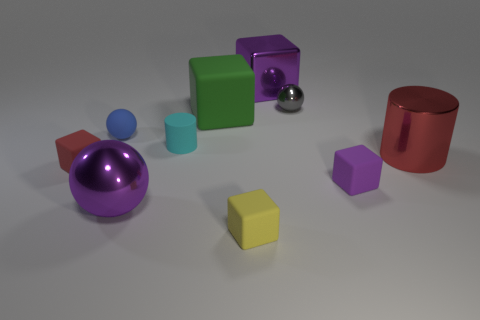There is a sphere that is the same color as the big metal block; what size is it?
Ensure brevity in your answer.  Large. What is the size of the metal thing on the left side of the big green thing?
Ensure brevity in your answer.  Large. There is a thing that is the same color as the big metallic cylinder; what is its material?
Ensure brevity in your answer.  Rubber. What is the color of the metallic object that is the same size as the blue sphere?
Provide a short and direct response. Gray. Is the size of the yellow object the same as the purple shiny cube?
Offer a terse response. No. What is the size of the cube that is both to the left of the small yellow object and right of the small blue matte ball?
Keep it short and to the point. Large. How many rubber objects are red blocks or cylinders?
Your response must be concise. 2. Are there more blocks in front of the small rubber cylinder than yellow metallic cylinders?
Ensure brevity in your answer.  Yes. What is the purple object that is left of the green rubber cube made of?
Your response must be concise. Metal. What number of tiny purple cubes have the same material as the small cyan cylinder?
Your response must be concise. 1. 